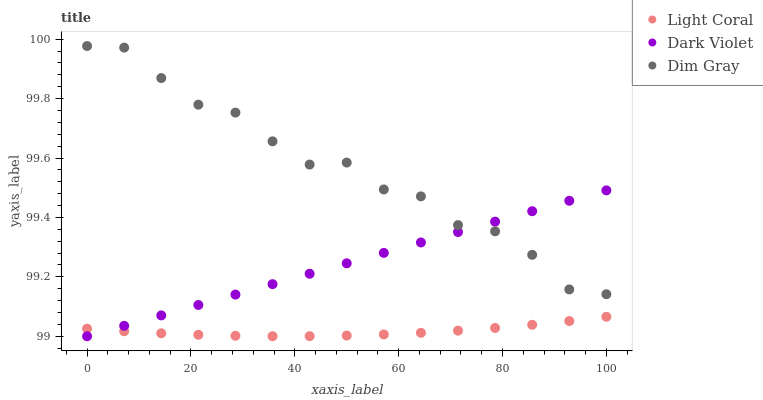Does Light Coral have the minimum area under the curve?
Answer yes or no. Yes. Does Dim Gray have the maximum area under the curve?
Answer yes or no. Yes. Does Dark Violet have the minimum area under the curve?
Answer yes or no. No. Does Dark Violet have the maximum area under the curve?
Answer yes or no. No. Is Dark Violet the smoothest?
Answer yes or no. Yes. Is Dim Gray the roughest?
Answer yes or no. Yes. Is Dim Gray the smoothest?
Answer yes or no. No. Is Dark Violet the roughest?
Answer yes or no. No. Does Dark Violet have the lowest value?
Answer yes or no. Yes. Does Dim Gray have the lowest value?
Answer yes or no. No. Does Dim Gray have the highest value?
Answer yes or no. Yes. Does Dark Violet have the highest value?
Answer yes or no. No. Is Light Coral less than Dim Gray?
Answer yes or no. Yes. Is Dim Gray greater than Light Coral?
Answer yes or no. Yes. Does Dark Violet intersect Dim Gray?
Answer yes or no. Yes. Is Dark Violet less than Dim Gray?
Answer yes or no. No. Is Dark Violet greater than Dim Gray?
Answer yes or no. No. Does Light Coral intersect Dim Gray?
Answer yes or no. No. 